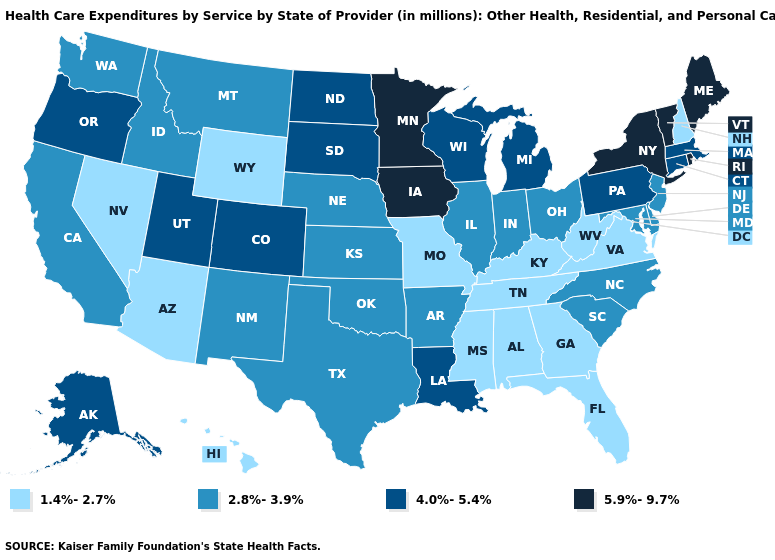What is the highest value in states that border Delaware?
Keep it brief. 4.0%-5.4%. Which states hav the highest value in the Northeast?
Write a very short answer. Maine, New York, Rhode Island, Vermont. Among the states that border New Jersey , which have the lowest value?
Write a very short answer. Delaware. What is the highest value in the South ?
Answer briefly. 4.0%-5.4%. What is the value of Mississippi?
Quick response, please. 1.4%-2.7%. Among the states that border Alabama , which have the highest value?
Concise answer only. Florida, Georgia, Mississippi, Tennessee. Name the states that have a value in the range 1.4%-2.7%?
Concise answer only. Alabama, Arizona, Florida, Georgia, Hawaii, Kentucky, Mississippi, Missouri, Nevada, New Hampshire, Tennessee, Virginia, West Virginia, Wyoming. Name the states that have a value in the range 1.4%-2.7%?
Give a very brief answer. Alabama, Arizona, Florida, Georgia, Hawaii, Kentucky, Mississippi, Missouri, Nevada, New Hampshire, Tennessee, Virginia, West Virginia, Wyoming. What is the value of Arizona?
Concise answer only. 1.4%-2.7%. What is the lowest value in the South?
Short answer required. 1.4%-2.7%. What is the value of Massachusetts?
Concise answer only. 4.0%-5.4%. What is the lowest value in states that border Wisconsin?
Answer briefly. 2.8%-3.9%. Does Texas have a lower value than South Dakota?
Keep it brief. Yes. Which states have the highest value in the USA?
Concise answer only. Iowa, Maine, Minnesota, New York, Rhode Island, Vermont. What is the value of Florida?
Short answer required. 1.4%-2.7%. 